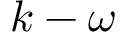Convert formula to latex. <formula><loc_0><loc_0><loc_500><loc_500>k - \omega</formula> 